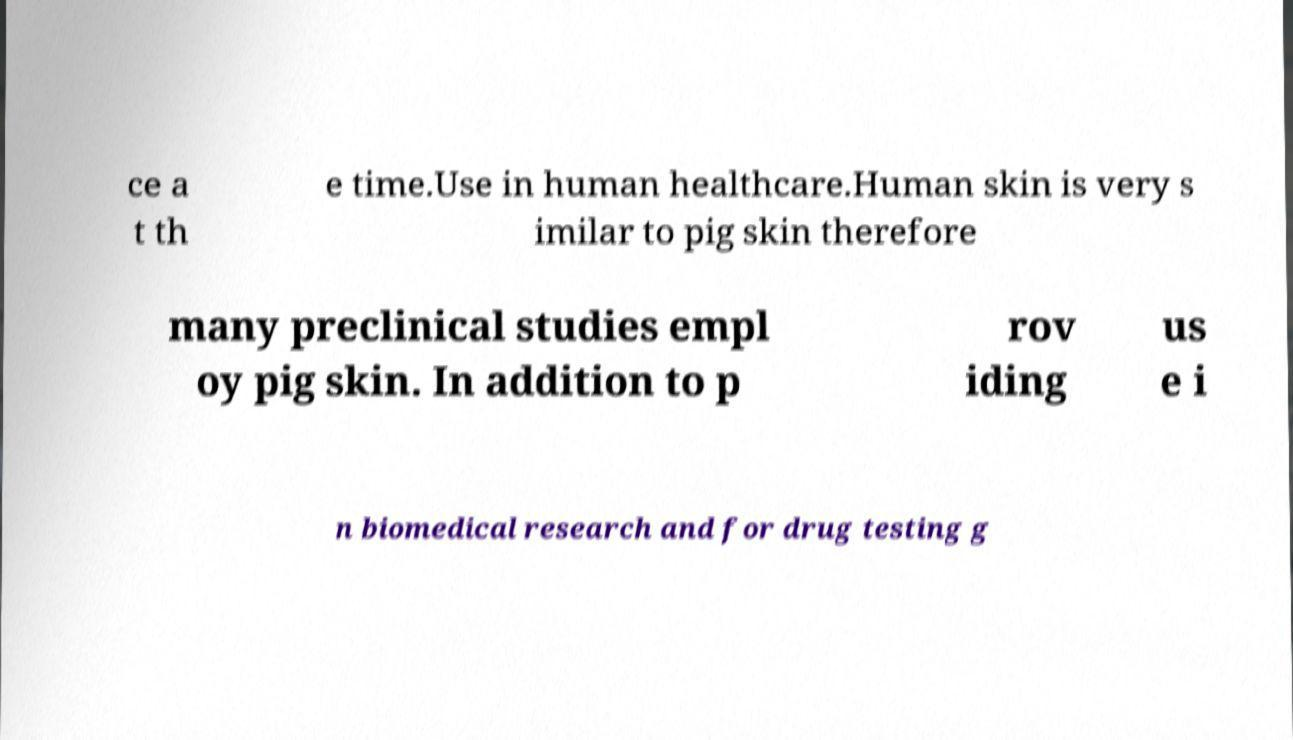Could you extract and type out the text from this image? ce a t th e time.Use in human healthcare.Human skin is very s imilar to pig skin therefore many preclinical studies empl oy pig skin. In addition to p rov iding us e i n biomedical research and for drug testing g 